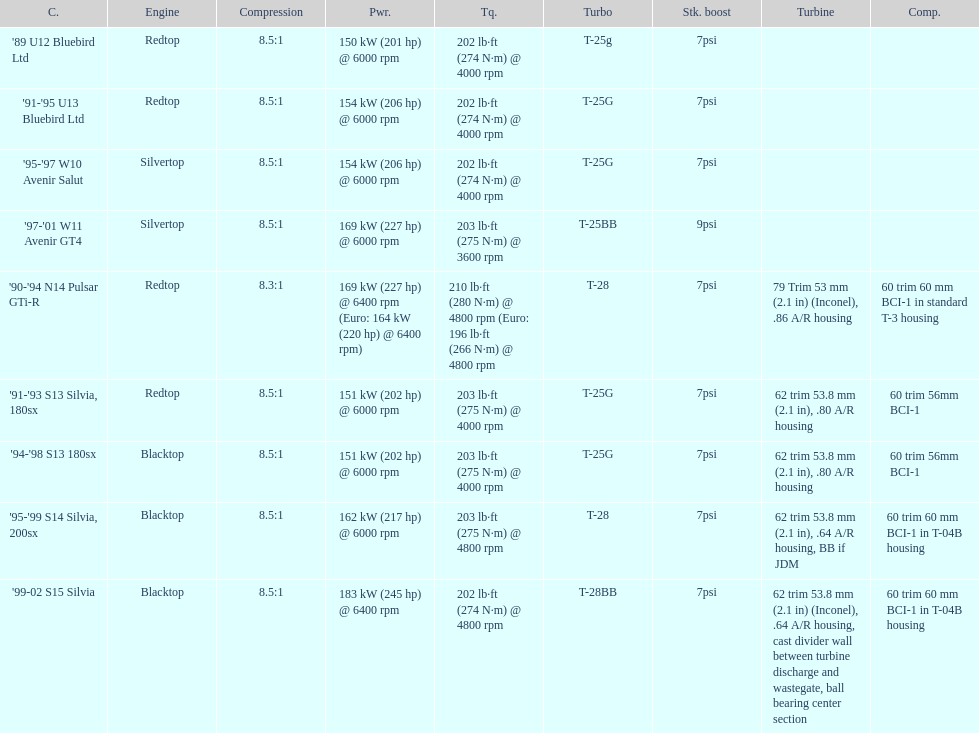Which car is the only one with more than 230 hp? '99-02 S15 Silvia. Would you be able to parse every entry in this table? {'header': ['C.', 'Engine', 'Compression', 'Pwr.', 'Tq.', 'Turbo', 'Stk. boost', 'Turbine', 'Comp.'], 'rows': [["'89 U12 Bluebird Ltd", 'Redtop', '8.5:1', '150\xa0kW (201\xa0hp) @ 6000 rpm', '202\xa0lb·ft (274\xa0N·m) @ 4000 rpm', 'T-25g', '7psi', '', ''], ["'91-'95 U13 Bluebird Ltd", 'Redtop', '8.5:1', '154\xa0kW (206\xa0hp) @ 6000 rpm', '202\xa0lb·ft (274\xa0N·m) @ 4000 rpm', 'T-25G', '7psi', '', ''], ["'95-'97 W10 Avenir Salut", 'Silvertop', '8.5:1', '154\xa0kW (206\xa0hp) @ 6000 rpm', '202\xa0lb·ft (274\xa0N·m) @ 4000 rpm', 'T-25G', '7psi', '', ''], ["'97-'01 W11 Avenir GT4", 'Silvertop', '8.5:1', '169\xa0kW (227\xa0hp) @ 6000 rpm', '203\xa0lb·ft (275\xa0N·m) @ 3600 rpm', 'T-25BB', '9psi', '', ''], ["'90-'94 N14 Pulsar GTi-R", 'Redtop', '8.3:1', '169\xa0kW (227\xa0hp) @ 6400 rpm (Euro: 164\xa0kW (220\xa0hp) @ 6400 rpm)', '210\xa0lb·ft (280\xa0N·m) @ 4800 rpm (Euro: 196\xa0lb·ft (266\xa0N·m) @ 4800 rpm', 'T-28', '7psi', '79 Trim 53\xa0mm (2.1\xa0in) (Inconel), .86 A/R housing', '60 trim 60\xa0mm BCI-1 in standard T-3 housing'], ["'91-'93 S13 Silvia, 180sx", 'Redtop', '8.5:1', '151\xa0kW (202\xa0hp) @ 6000 rpm', '203\xa0lb·ft (275\xa0N·m) @ 4000 rpm', 'T-25G', '7psi', '62 trim 53.8\xa0mm (2.1\xa0in), .80 A/R housing', '60 trim 56mm BCI-1'], ["'94-'98 S13 180sx", 'Blacktop', '8.5:1', '151\xa0kW (202\xa0hp) @ 6000 rpm', '203\xa0lb·ft (275\xa0N·m) @ 4000 rpm', 'T-25G', '7psi', '62 trim 53.8\xa0mm (2.1\xa0in), .80 A/R housing', '60 trim 56mm BCI-1'], ["'95-'99 S14 Silvia, 200sx", 'Blacktop', '8.5:1', '162\xa0kW (217\xa0hp) @ 6000 rpm', '203\xa0lb·ft (275\xa0N·m) @ 4800 rpm', 'T-28', '7psi', '62 trim 53.8\xa0mm (2.1\xa0in), .64 A/R housing, BB if JDM', '60 trim 60\xa0mm BCI-1 in T-04B housing'], ["'99-02 S15 Silvia", 'Blacktop', '8.5:1', '183\xa0kW (245\xa0hp) @ 6400 rpm', '202\xa0lb·ft (274\xa0N·m) @ 4800 rpm', 'T-28BB', '7psi', '62 trim 53.8\xa0mm (2.1\xa0in) (Inconel), .64 A/R housing, cast divider wall between turbine discharge and wastegate, ball bearing center section', '60 trim 60\xa0mm BCI-1 in T-04B housing']]} 